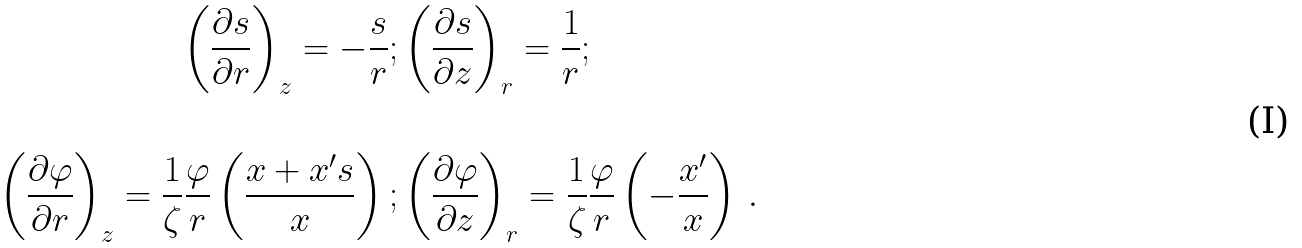<formula> <loc_0><loc_0><loc_500><loc_500>\left ( \frac { \partial s } { \partial r } \right ) _ { z } = - \frac { s } { r } ; & \left ( \frac { \partial s } { \partial z } \right ) _ { r } = \frac { 1 } { r } ; \\ & \\ \left ( \frac { \partial \varphi } { \partial r } \right ) _ { z } = \frac { 1 } { \zeta } \frac { \varphi } { r } \left ( \frac { x + x ^ { \prime } s } { x } \right ) ; & \left ( \frac { \partial \varphi } { \partial z } \right ) _ { r } = \frac { 1 } { \zeta } \frac { \varphi } { r } \left ( - \frac { x ^ { \prime } } { x } \right ) \, .</formula> 